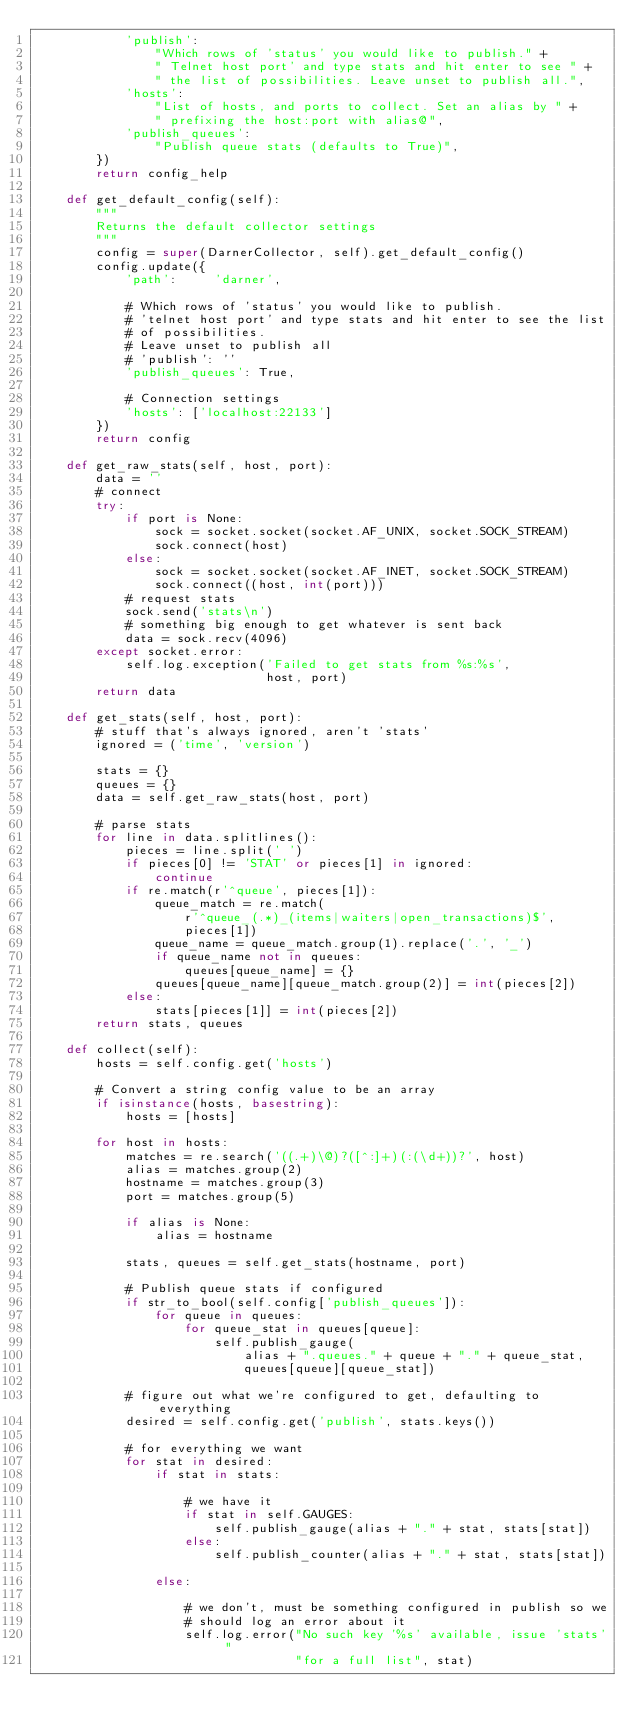Convert code to text. <code><loc_0><loc_0><loc_500><loc_500><_Python_>            'publish':
                "Which rows of 'status' you would like to publish." +
                " Telnet host port' and type stats and hit enter to see " +
                " the list of possibilities. Leave unset to publish all.",
            'hosts':
                "List of hosts, and ports to collect. Set an alias by " +
                " prefixing the host:port with alias@",
            'publish_queues':
                "Publish queue stats (defaults to True)",
        })
        return config_help

    def get_default_config(self):
        """
        Returns the default collector settings
        """
        config = super(DarnerCollector, self).get_default_config()
        config.update({
            'path':     'darner',

            # Which rows of 'status' you would like to publish.
            # 'telnet host port' and type stats and hit enter to see the list
            # of possibilities.
            # Leave unset to publish all
            # 'publish': ''
            'publish_queues': True,

            # Connection settings
            'hosts': ['localhost:22133']
        })
        return config

    def get_raw_stats(self, host, port):
        data = ''
        # connect
        try:
            if port is None:
                sock = socket.socket(socket.AF_UNIX, socket.SOCK_STREAM)
                sock.connect(host)
            else:
                sock = socket.socket(socket.AF_INET, socket.SOCK_STREAM)
                sock.connect((host, int(port)))
            # request stats
            sock.send('stats\n')
            # something big enough to get whatever is sent back
            data = sock.recv(4096)
        except socket.error:
            self.log.exception('Failed to get stats from %s:%s',
                               host, port)
        return data

    def get_stats(self, host, port):
        # stuff that's always ignored, aren't 'stats'
        ignored = ('time', 'version')

        stats = {}
        queues = {}
        data = self.get_raw_stats(host, port)

        # parse stats
        for line in data.splitlines():
            pieces = line.split(' ')
            if pieces[0] != 'STAT' or pieces[1] in ignored:
                continue
            if re.match(r'^queue', pieces[1]):
                queue_match = re.match(
                    r'^queue_(.*)_(items|waiters|open_transactions)$',
                    pieces[1])
                queue_name = queue_match.group(1).replace('.', '_')
                if queue_name not in queues:
                    queues[queue_name] = {}
                queues[queue_name][queue_match.group(2)] = int(pieces[2])
            else:
                stats[pieces[1]] = int(pieces[2])
        return stats, queues

    def collect(self):
        hosts = self.config.get('hosts')

        # Convert a string config value to be an array
        if isinstance(hosts, basestring):
            hosts = [hosts]

        for host in hosts:
            matches = re.search('((.+)\@)?([^:]+)(:(\d+))?', host)
            alias = matches.group(2)
            hostname = matches.group(3)
            port = matches.group(5)

            if alias is None:
                alias = hostname

            stats, queues = self.get_stats(hostname, port)

            # Publish queue stats if configured
            if str_to_bool(self.config['publish_queues']):
                for queue in queues:
                    for queue_stat in queues[queue]:
                        self.publish_gauge(
                            alias + ".queues." + queue + "." + queue_stat,
                            queues[queue][queue_stat])

            # figure out what we're configured to get, defaulting to everything
            desired = self.config.get('publish', stats.keys())

            # for everything we want
            for stat in desired:
                if stat in stats:

                    # we have it
                    if stat in self.GAUGES:
                        self.publish_gauge(alias + "." + stat, stats[stat])
                    else:
                        self.publish_counter(alias + "." + stat, stats[stat])

                else:

                    # we don't, must be something configured in publish so we
                    # should log an error about it
                    self.log.error("No such key '%s' available, issue 'stats' "
                                   "for a full list", stat)
</code> 